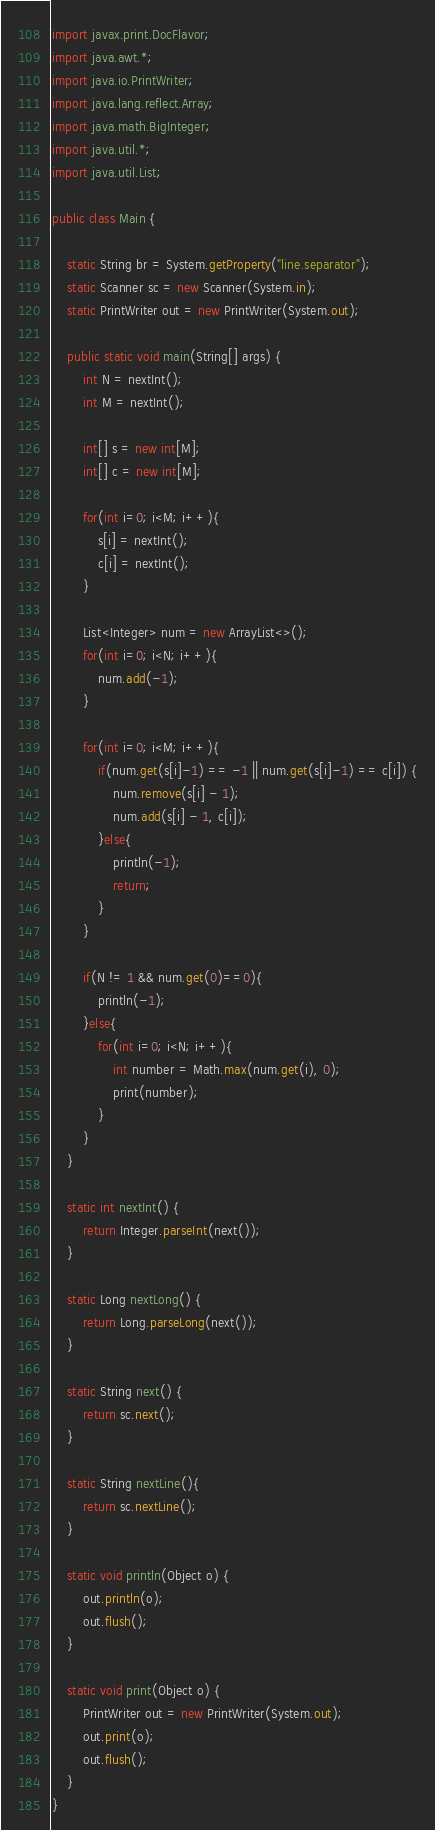<code> <loc_0><loc_0><loc_500><loc_500><_Java_>import javax.print.DocFlavor;
import java.awt.*;
import java.io.PrintWriter;
import java.lang.reflect.Array;
import java.math.BigInteger;
import java.util.*;
import java.util.List;

public class Main {

    static String br = System.getProperty("line.separator");
    static Scanner sc = new Scanner(System.in);
    static PrintWriter out = new PrintWriter(System.out);

    public static void main(String[] args) {
        int N = nextInt();
        int M = nextInt();

        int[] s = new int[M];
        int[] c = new int[M];

        for(int i=0; i<M; i++){
            s[i] = nextInt();
            c[i] = nextInt();
        }

        List<Integer> num = new ArrayList<>();
        for(int i=0; i<N; i++){
            num.add(-1);
        }

        for(int i=0; i<M; i++){
            if(num.get(s[i]-1) == -1 || num.get(s[i]-1) == c[i]) {
                num.remove(s[i] - 1);
                num.add(s[i] - 1, c[i]);
            }else{
                println(-1);
                return;
            }
        }

        if(N != 1 && num.get(0)==0){
            println(-1);
        }else{
            for(int i=0; i<N; i++){
                int number = Math.max(num.get(i), 0);
                print(number);
            }
        }
    }

    static int nextInt() {
        return Integer.parseInt(next());
    }

    static Long nextLong() {
        return Long.parseLong(next());
    }

    static String next() {
        return sc.next();
    }

    static String nextLine(){
        return sc.nextLine();
    }

    static void println(Object o) {
        out.println(o);
        out.flush();
    }

    static void print(Object o) {
        PrintWriter out = new PrintWriter(System.out);
        out.print(o);
        out.flush();
    }
}
</code> 